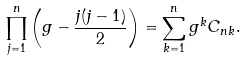Convert formula to latex. <formula><loc_0><loc_0><loc_500><loc_500>\prod _ { j = 1 } ^ { n } \left ( g - \frac { j ( j - 1 ) } { 2 } \right ) = \sum _ { k = 1 } ^ { n } g ^ { k } C _ { n k } .</formula> 